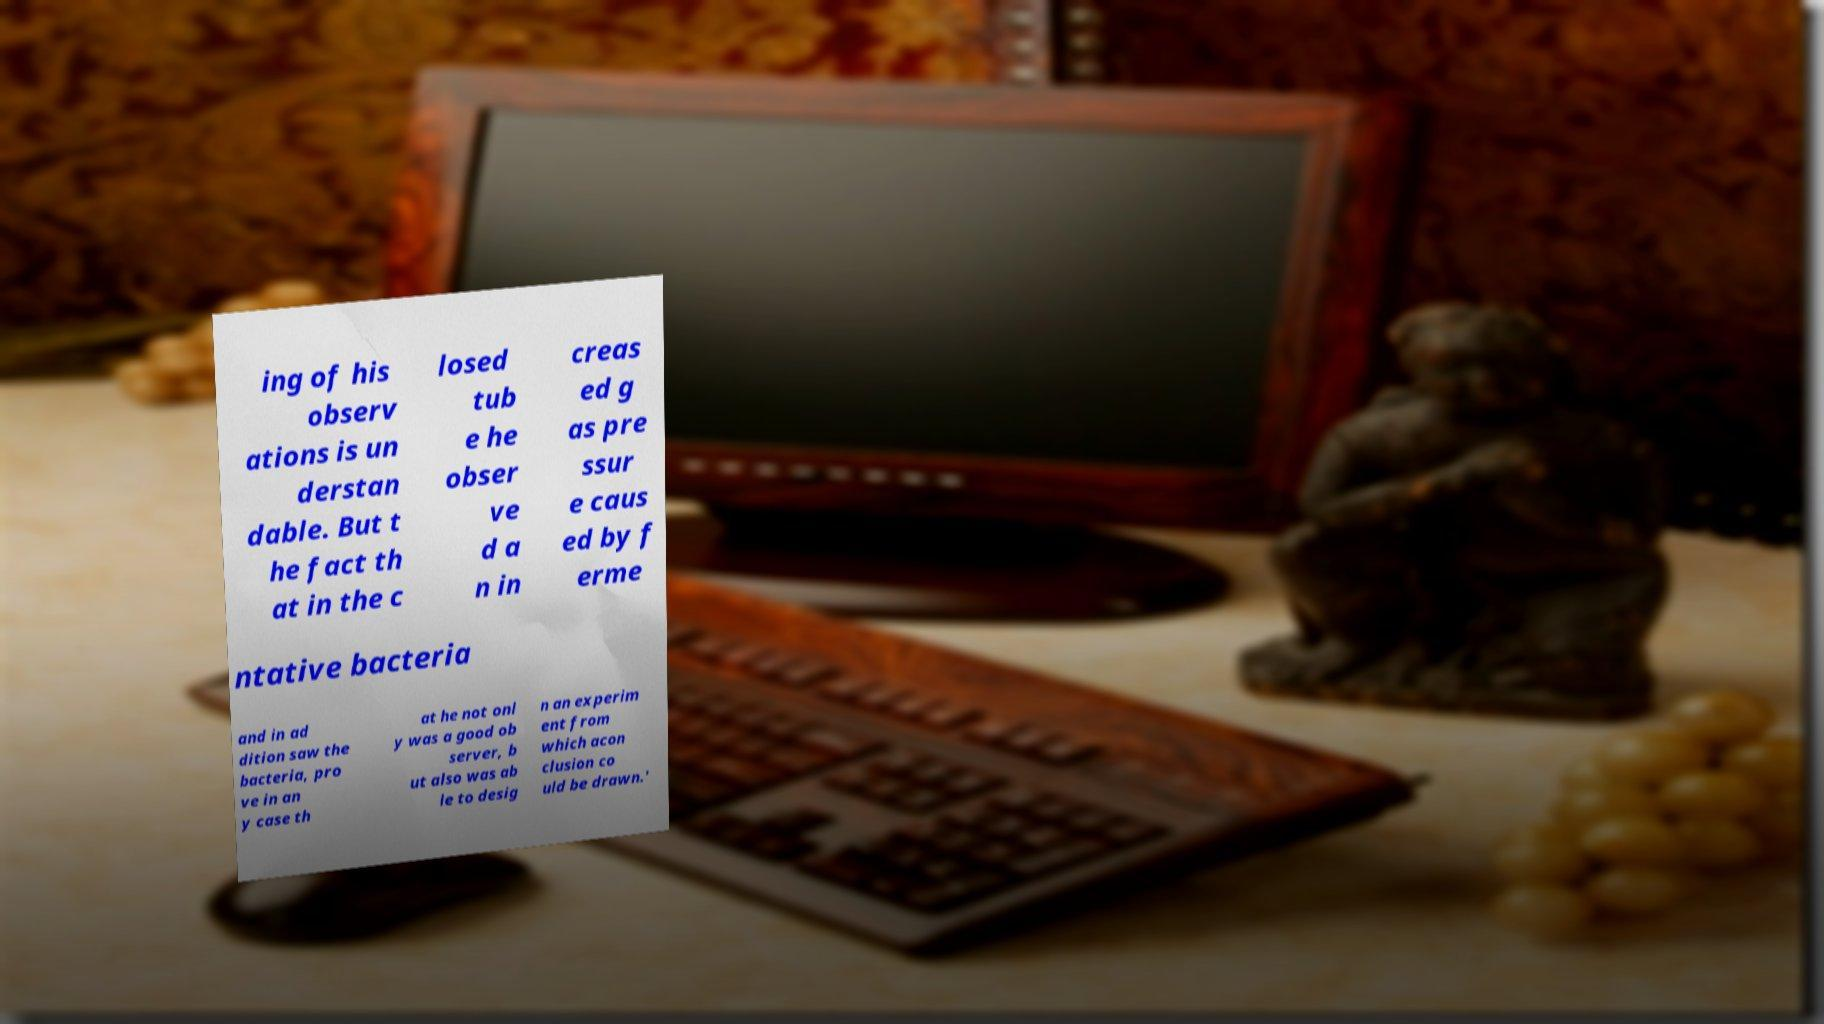Please read and relay the text visible in this image. What does it say? ing of his observ ations is un derstan dable. But t he fact th at in the c losed tub e he obser ve d a n in creas ed g as pre ssur e caus ed by f erme ntative bacteria and in ad dition saw the bacteria, pro ve in an y case th at he not onl y was a good ob server, b ut also was ab le to desig n an experim ent from which acon clusion co uld be drawn.' 